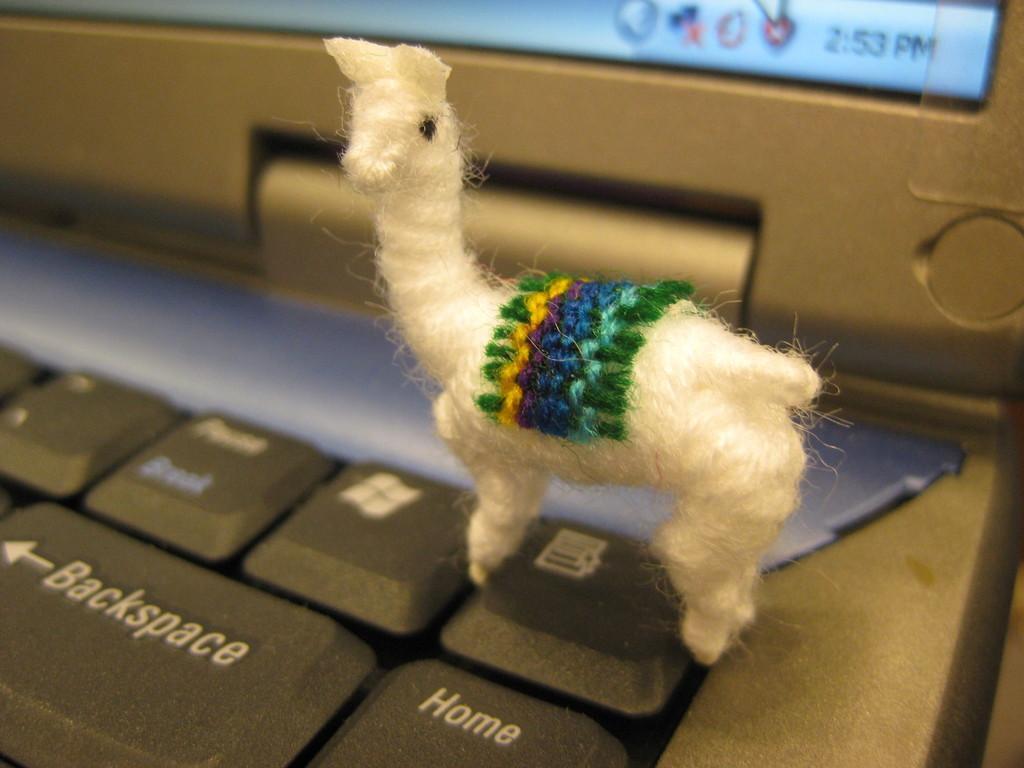In one or two sentences, can you explain what this image depicts? In this picture we can see a toy in the front, in the background there is a laptop, we can see keys of the laptop. 